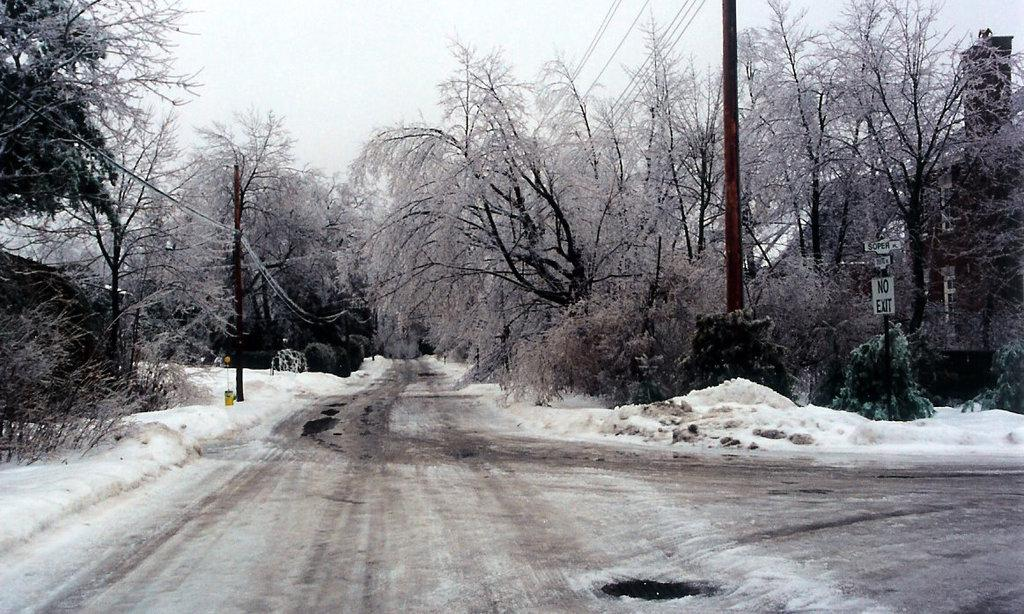What is the main feature of the image? There is a road in the image. How is the road affected by the weather? The road is covered with snow. What can be seen on either side of the road? There are trees on either side of the road. What is present on the right side of the image? There is a sign board on the right side of the image. What type of stew is being served on the island in the image? There is no island or stew present in the image; it features a snow-covered road with trees and a sign board. 